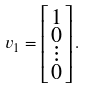Convert formula to latex. <formula><loc_0><loc_0><loc_500><loc_500>v _ { 1 } = \left [ \begin{smallmatrix} 1 \\ 0 \\ \vdots \\ 0 \end{smallmatrix} \right ] .</formula> 